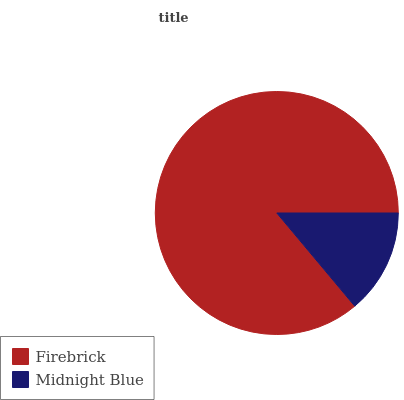Is Midnight Blue the minimum?
Answer yes or no. Yes. Is Firebrick the maximum?
Answer yes or no. Yes. Is Midnight Blue the maximum?
Answer yes or no. No. Is Firebrick greater than Midnight Blue?
Answer yes or no. Yes. Is Midnight Blue less than Firebrick?
Answer yes or no. Yes. Is Midnight Blue greater than Firebrick?
Answer yes or no. No. Is Firebrick less than Midnight Blue?
Answer yes or no. No. Is Firebrick the high median?
Answer yes or no. Yes. Is Midnight Blue the low median?
Answer yes or no. Yes. Is Midnight Blue the high median?
Answer yes or no. No. Is Firebrick the low median?
Answer yes or no. No. 